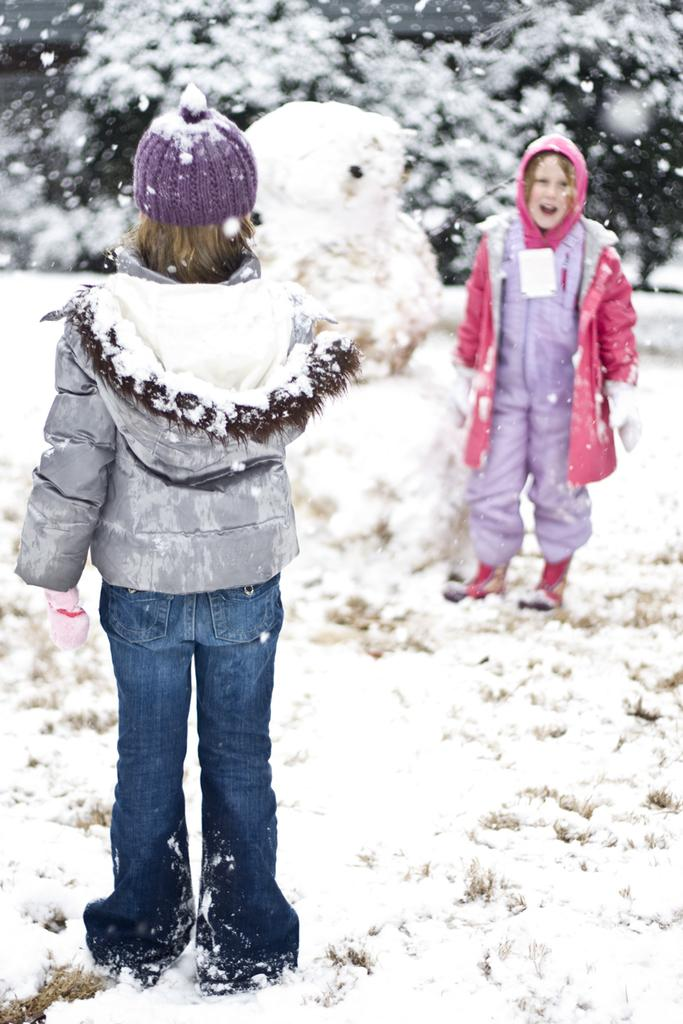How many people are in the image? There are two persons standing on the road in the image. What is the weather like in the image? Snow and ice are present in the image, indicating a cold and likely snowy or icy environment. What type of natural environment is visible in the image? There are trees in the image, suggesting a forested or wooded area. When was the image likely taken? The image was likely taken during the day, as shadows and lighting suggest daylight conditions. What type of effect does the person on the left have on the person on the right's mouth? There is no interaction between the two persons in the image that would suggest any effect on the person on the right's mouth. 